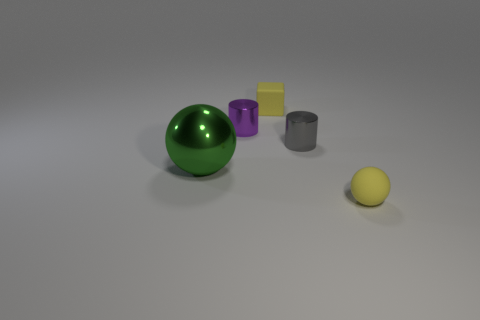Are there more small gray cylinders on the right side of the gray metallic cylinder than purple objects that are on the right side of the rubber ball?
Your answer should be compact. No. Are there any other things that have the same size as the green shiny thing?
Offer a very short reply. No. What number of cylinders are either tiny gray metal objects or tiny shiny objects?
Give a very brief answer. 2. How many things are either metallic objects that are on the right side of the green thing or tiny spheres?
Ensure brevity in your answer.  3. There is a gray thing in front of the shiny cylinder that is on the left side of the yellow matte thing behind the large green shiny ball; what shape is it?
Give a very brief answer. Cylinder. What number of other yellow rubber objects have the same shape as the large object?
Offer a very short reply. 1. There is a small ball that is the same color as the tiny cube; what is its material?
Keep it short and to the point. Rubber. Is the material of the big ball the same as the tiny purple cylinder?
Provide a succinct answer. Yes. There is a yellow matte thing in front of the rubber object that is behind the gray metallic cylinder; how many metallic spheres are behind it?
Provide a short and direct response. 1. Is there another small block made of the same material as the yellow block?
Provide a succinct answer. No. 